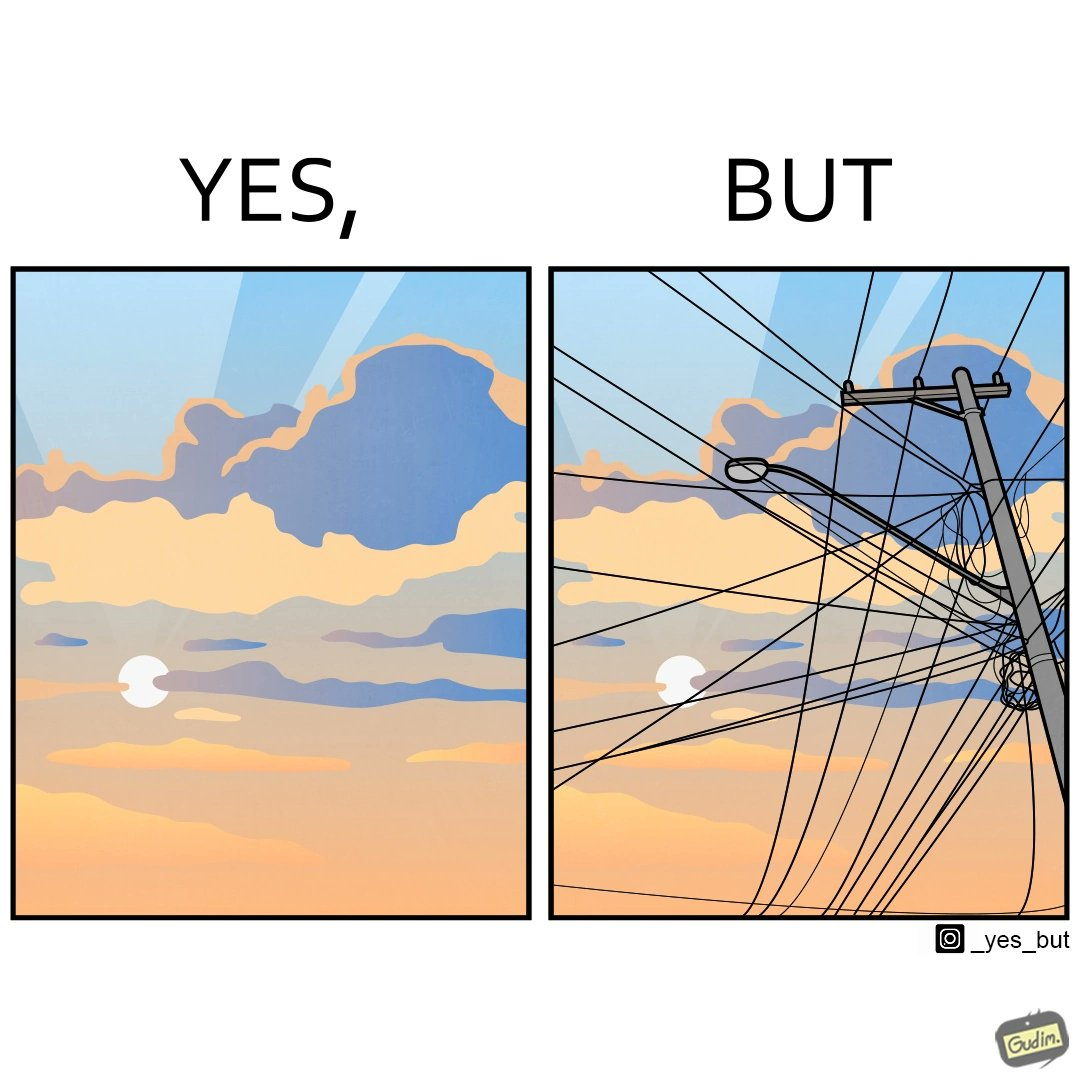Provide a description of this image. The image is ironic, because in the first image clear sky is visible but in the second image the same view is getting blocked due to the electricity pole 